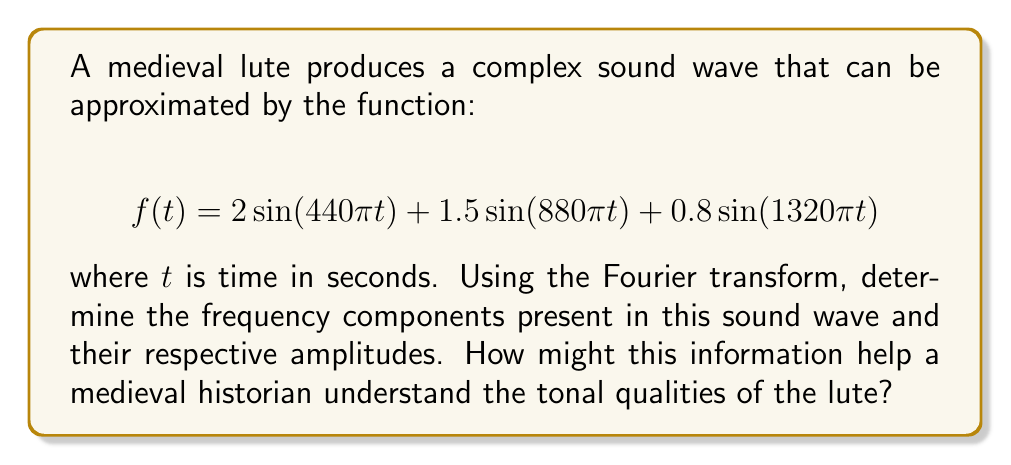Show me your answer to this math problem. To analyze the frequency components of the lute's sound wave, we need to apply the Fourier transform to the given function. The Fourier transform converts a time-domain signal into its frequency-domain representation.

For a sinusoidal function of the form $A\sin(2\pi ft)$, where $A$ is the amplitude and $f$ is the frequency in Hz, the Fourier transform will produce a pair of delta functions at $\pm f$ with amplitude $A/2$.

Let's break down the given function:

1. $2\sin(440\pi t)$:
   Frequency: $f_1 = 440\pi/(2\pi) = 220$ Hz
   Amplitude: $A_1 = 2$

2. $1.5\sin(880\pi t)$:
   Frequency: $f_2 = 880\pi/(2\pi) = 440$ Hz
   Amplitude: $A_2 = 1.5$

3. $0.8\sin(1320\pi t)$:
   Frequency: $f_3 = 1320\pi/(2\pi) = 660$ Hz
   Amplitude: $A_3 = 0.8$

The Fourier transform will show peaks at these frequencies with half the original amplitudes:

- 220 Hz with amplitude 1
- 440 Hz with amplitude 0.75
- 660 Hz with amplitude 0.4

For a medieval historian, this information reveals:

1. The fundamental frequency (220 Hz) corresponds to the note A3, which was likely the main note played.
2. The presence of harmonics at 440 Hz (2nd harmonic) and 660 Hz (3rd harmonic) contributes to the lute's characteristic timbre.
3. The decreasing amplitudes of higher harmonics indicate a relatively mellow sound, typical of plucked string instruments like the lute.

This analysis helps historians understand the tonal qualities of medieval lutes, compare them with other instruments of the era, and potentially reconstruct the sound of medieval music more accurately.
Answer: The frequency components and their amplitudes in the Fourier transform of the lute's sound wave are:

1. 220 Hz with amplitude 1
2. 440 Hz with amplitude 0.75
3. 660 Hz with amplitude 0.4

This information reveals the fundamental frequency (220 Hz, note A3) and two harmonics, providing insight into the lute's timbre and tonal characteristics, which is valuable for understanding and reconstructing medieval music. 